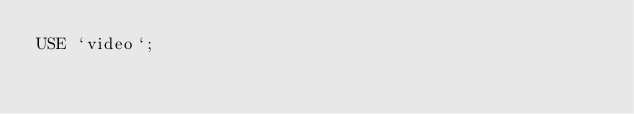Convert code to text. <code><loc_0><loc_0><loc_500><loc_500><_SQL_>USE `video`;
</code> 